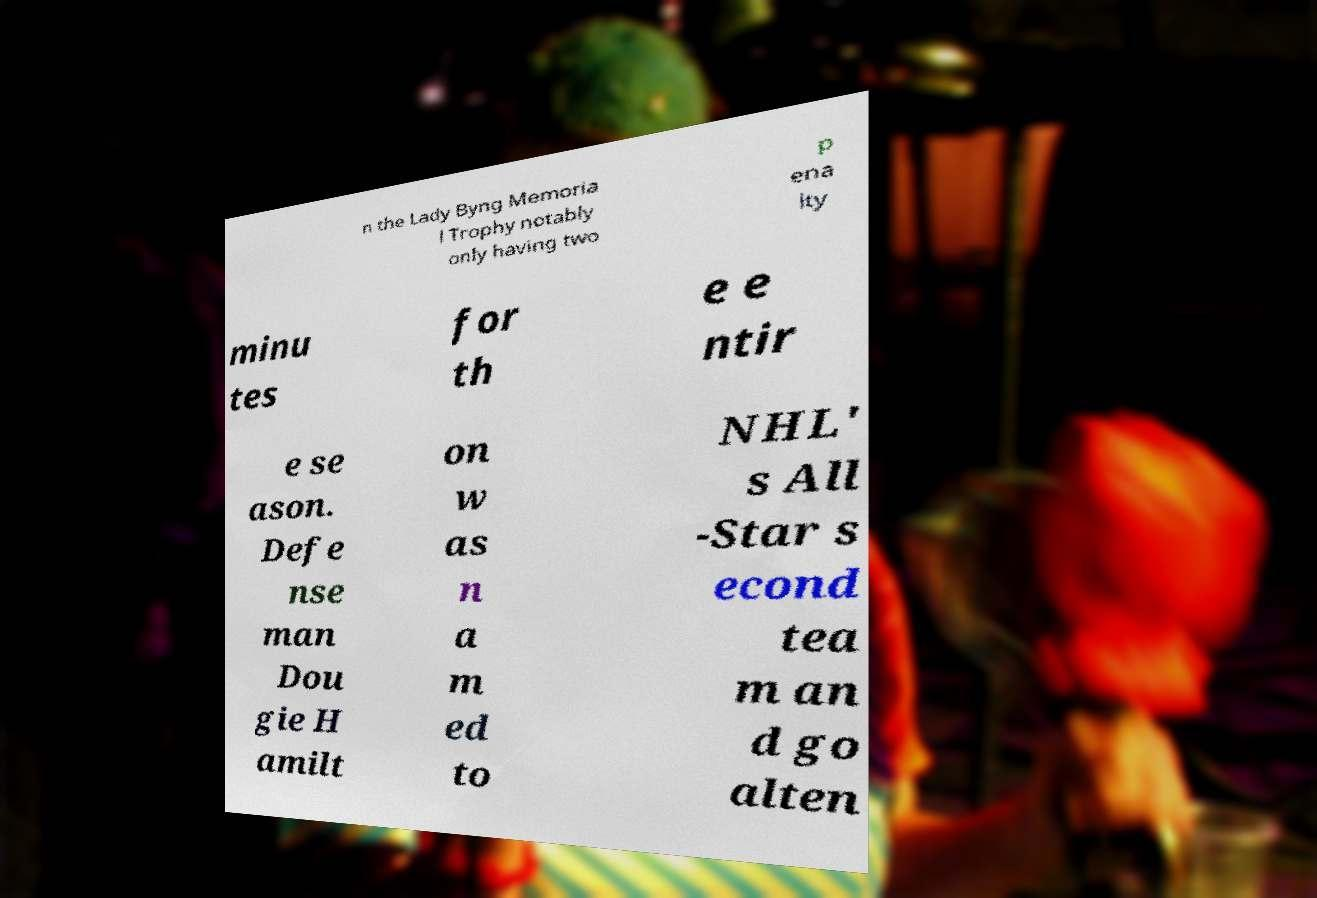Could you extract and type out the text from this image? n the Lady Byng Memoria l Trophy notably only having two p ena lty minu tes for th e e ntir e se ason. Defe nse man Dou gie H amilt on w as n a m ed to NHL' s All -Star s econd tea m an d go alten 